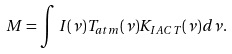Convert formula to latex. <formula><loc_0><loc_0><loc_500><loc_500>M = \int I ( \nu ) T _ { a t m } ( \nu ) K _ { I A C T } ( \nu ) d \nu .</formula> 